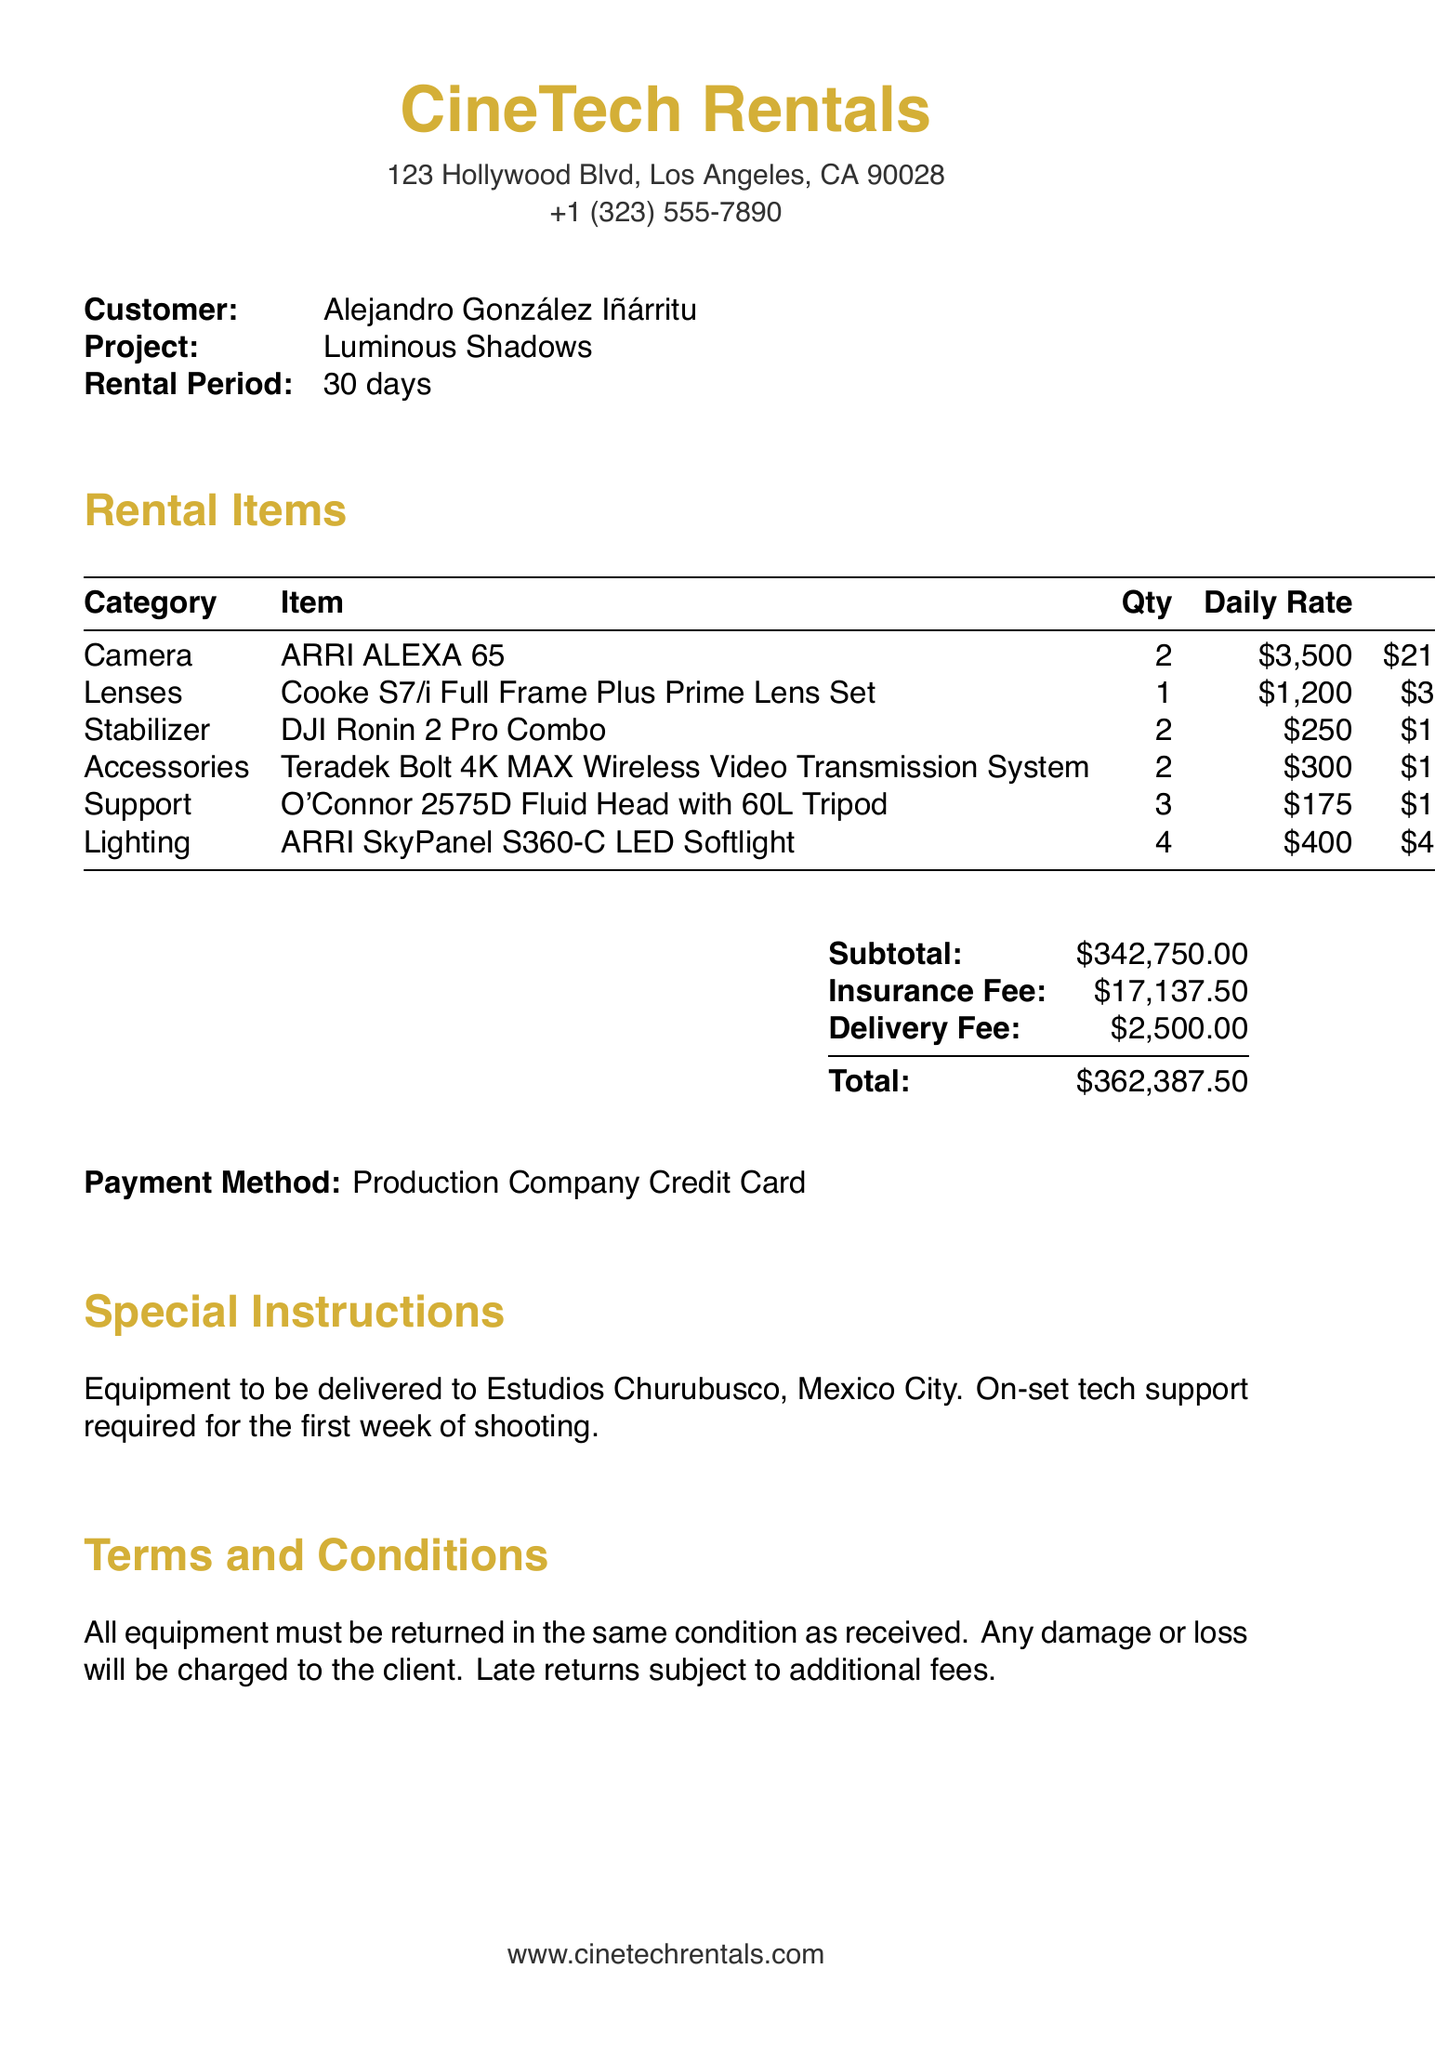What is the company name? The company name is provided at the top of the document.
Answer: CineTech Rentals Who is the customer? The customer name is listed in the document and identifies who is renting the equipment.
Answer: Alejandro González Iñárritu What is the rental period? The document specifies how long the rental is valid for, clearly marked in the customer information section.
Answer: 30 days How many ARRI ALEXA 65 cameras are rented? The quantity of each item rented is stated in the document, specifically for cameras.
Answer: 2 What is the total rental cost? The total cost is summarized at the bottom of the document, combining all charges including fees.
Answer: $362,387.50 What is the delivery fee? The delivery fee is explicitly mentioned in the summary section of the document, detailing additional service costs.
Answer: $2,500.00 Where is the equipment to be delivered? The delivery address is found in the special instructions section, which specifies where the equipment will go.
Answer: Estudios Churubusco, Mexico City What type of support is required on set? The special instructions indicate any additional services requested during the rental period.
Answer: On-set tech support What is the insurance fee? The insurance fee is included in the summary section of the document and is clearly listed.
Answer: $17,137.50 What happens if equipment is returned late? The terms and conditions outline the consequences of late returns, which include fees.
Answer: Subject to additional fees 